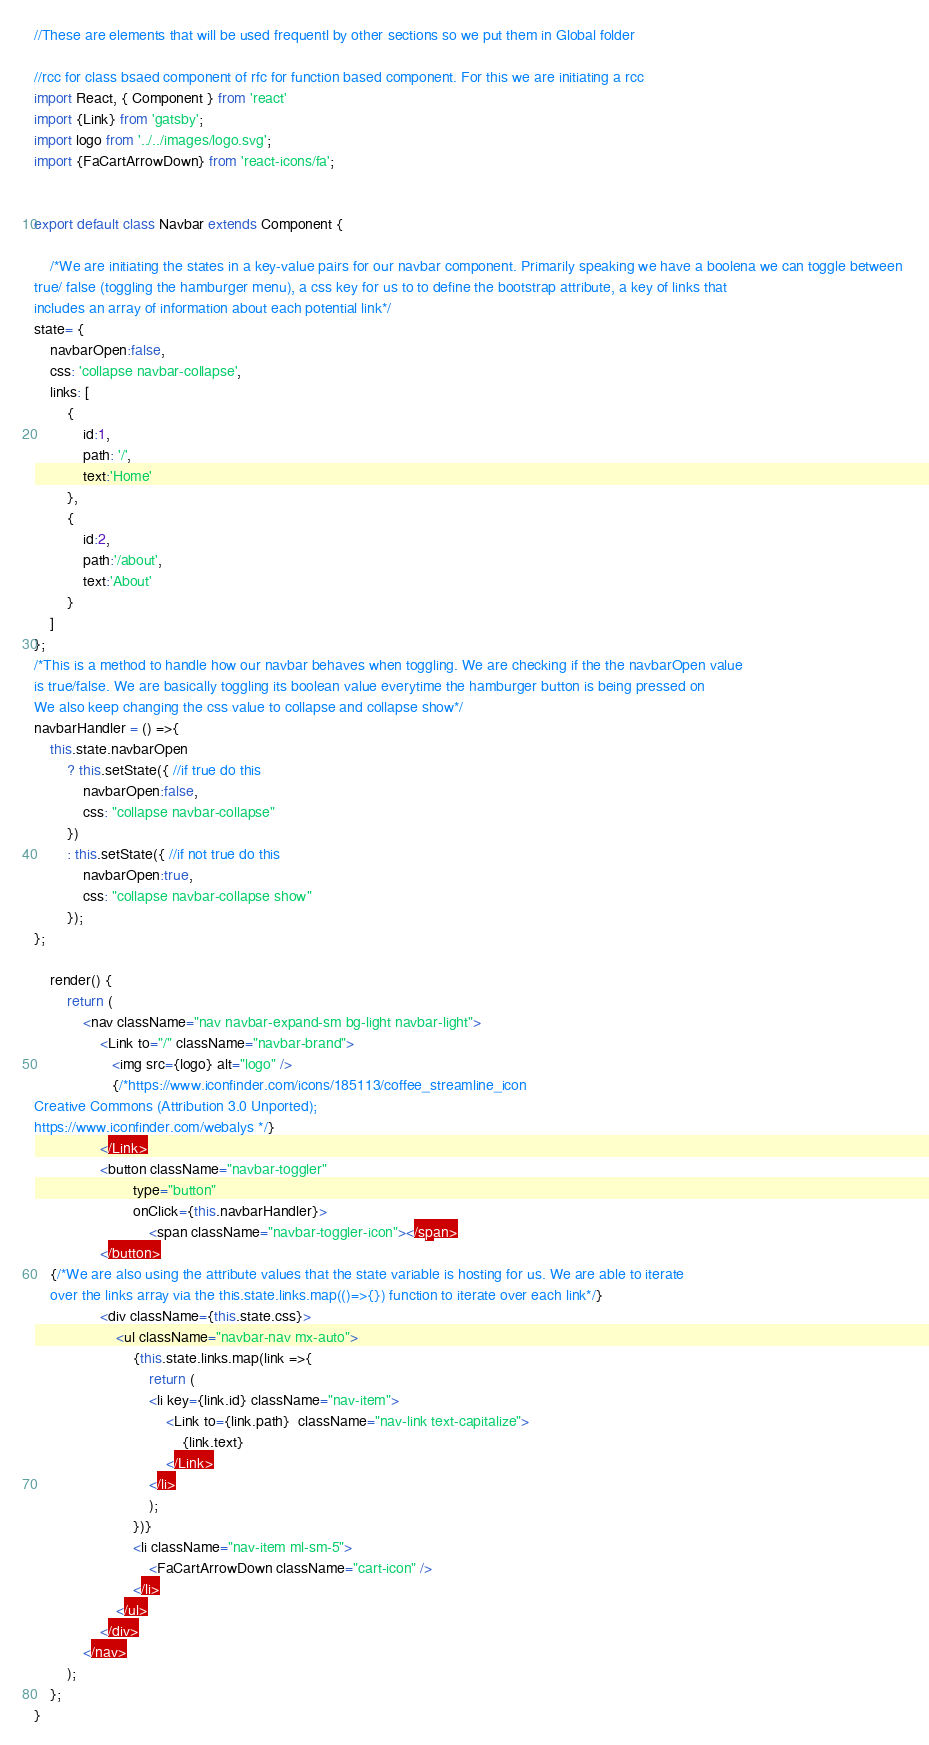<code> <loc_0><loc_0><loc_500><loc_500><_JavaScript_>//These are elements that will be used frequentl by other sections so we put them in Global folder

//rcc for class bsaed component of rfc for function based component. For this we are initiating a rcc
import React, { Component } from 'react'
import {Link} from 'gatsby';
import logo from '../../images/logo.svg';
import {FaCartArrowDown} from 'react-icons/fa';


export default class Navbar extends Component {

    /*We are initiating the states in a key-value pairs for our navbar component. Primarily speaking we have a boolena we can toggle between 
true/ false (toggling the hamburger menu), a css key for us to to define the bootstrap attribute, a key of links that
includes an array of information about each potential link*/
state= {
    navbarOpen:false,
    css: 'collapse navbar-collapse',
    links: [
        {
            id:1,
            path: '/',
            text:'Home'
        },
        {
            id:2,
            path:'/about',
            text:'About'
        }
    ]
};
/*This is a method to handle how our navbar behaves when toggling. We are checking if the the navbarOpen value
is true/false. We are basically toggling its boolean value everytime the hamburger button is being pressed on
We also keep changing the css value to collapse and collapse show*/
navbarHandler = () =>{
    this.state.navbarOpen
        ? this.setState({ //if true do this
            navbarOpen:false,
            css: "collapse navbar-collapse"
        })
        : this.setState({ //if not true do this
            navbarOpen:true,
            css: "collapse navbar-collapse show"
        });
};

    render() {
        return (
            <nav className="nav navbar-expand-sm bg-light navbar-light">
                <Link to="/" className="navbar-brand">
                   <img src={logo} alt="logo" /> 
                   {/*https://www.iconfinder.com/icons/185113/coffee_streamline_icon
Creative Commons (Attribution 3.0 Unported);
https://www.iconfinder.com/webalys */}
                </Link>
                <button className="navbar-toggler"
                        type="button" 
                        onClick={this.navbarHandler}>
                            <span className="navbar-toggler-icon"></span>
                </button>
    {/*We are also using the attribute values that the state variable is hosting for us. We are able to iterate
    over the links array via the this.state.links.map(()=>{}) function to iterate over each link*/}
                <div className={this.state.css}>
                    <ul className="navbar-nav mx-auto">
                        {this.state.links.map(link =>{
                            return (
                            <li key={link.id} className="nav-item">
                                <Link to={link.path}  className="nav-link text-capitalize">
                                    {link.text}
                                </Link>
                            </li>
                            );
                        })}
                        <li className="nav-item ml-sm-5">
                            <FaCartArrowDown className="cart-icon" />
                        </li>
                    </ul>
                </div>
            </nav>
        );
    };
}

</code> 